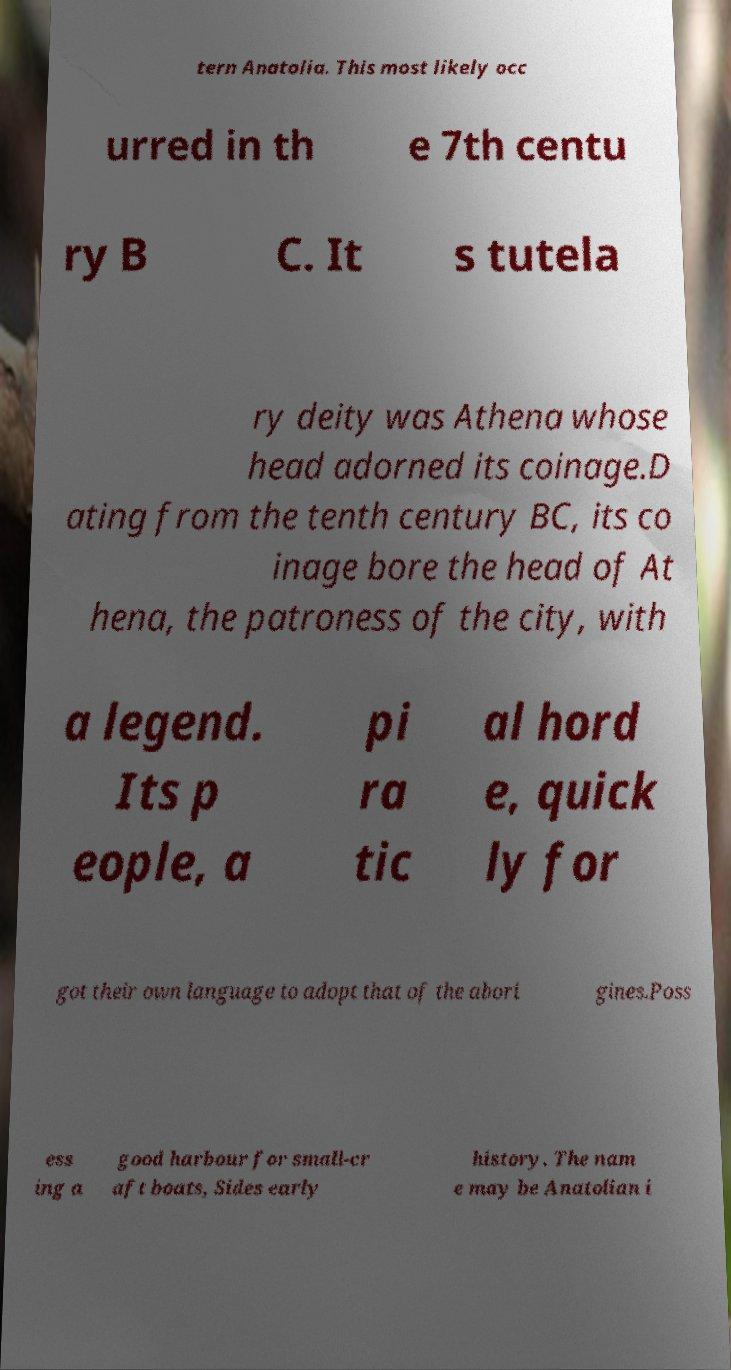Please read and relay the text visible in this image. What does it say? tern Anatolia. This most likely occ urred in th e 7th centu ry B C. It s tutela ry deity was Athena whose head adorned its coinage.D ating from the tenth century BC, its co inage bore the head of At hena, the patroness of the city, with a legend. Its p eople, a pi ra tic al hord e, quick ly for got their own language to adopt that of the abori gines.Poss ess ing a good harbour for small-cr aft boats, Sides early history. The nam e may be Anatolian i 